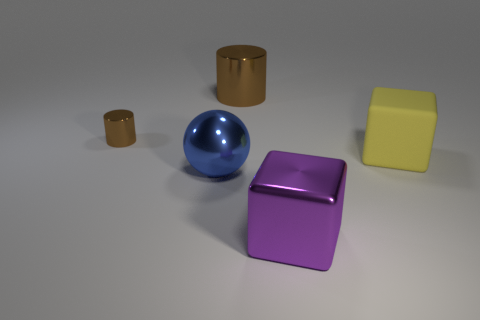Are there any other things that are the same material as the yellow object?
Give a very brief answer. No. What is the color of the large cube that is to the right of the metal object in front of the big blue metal object?
Your response must be concise. Yellow. Does the small thing have the same color as the large metallic thing behind the ball?
Offer a terse response. Yes. There is a thing that is both in front of the tiny object and behind the ball; what is its material?
Provide a succinct answer. Rubber. Is there a sphere that has the same size as the yellow thing?
Provide a short and direct response. Yes. What material is the yellow cube that is the same size as the purple block?
Offer a very short reply. Rubber. How many metallic cylinders are behind the tiny object?
Keep it short and to the point. 1. There is a object on the right side of the purple metallic block; does it have the same shape as the purple metallic object?
Give a very brief answer. Yes. Are there any other brown objects that have the same shape as the small shiny object?
Keep it short and to the point. Yes. What shape is the metallic object in front of the big blue shiny object in front of the rubber thing?
Your answer should be compact. Cube. 